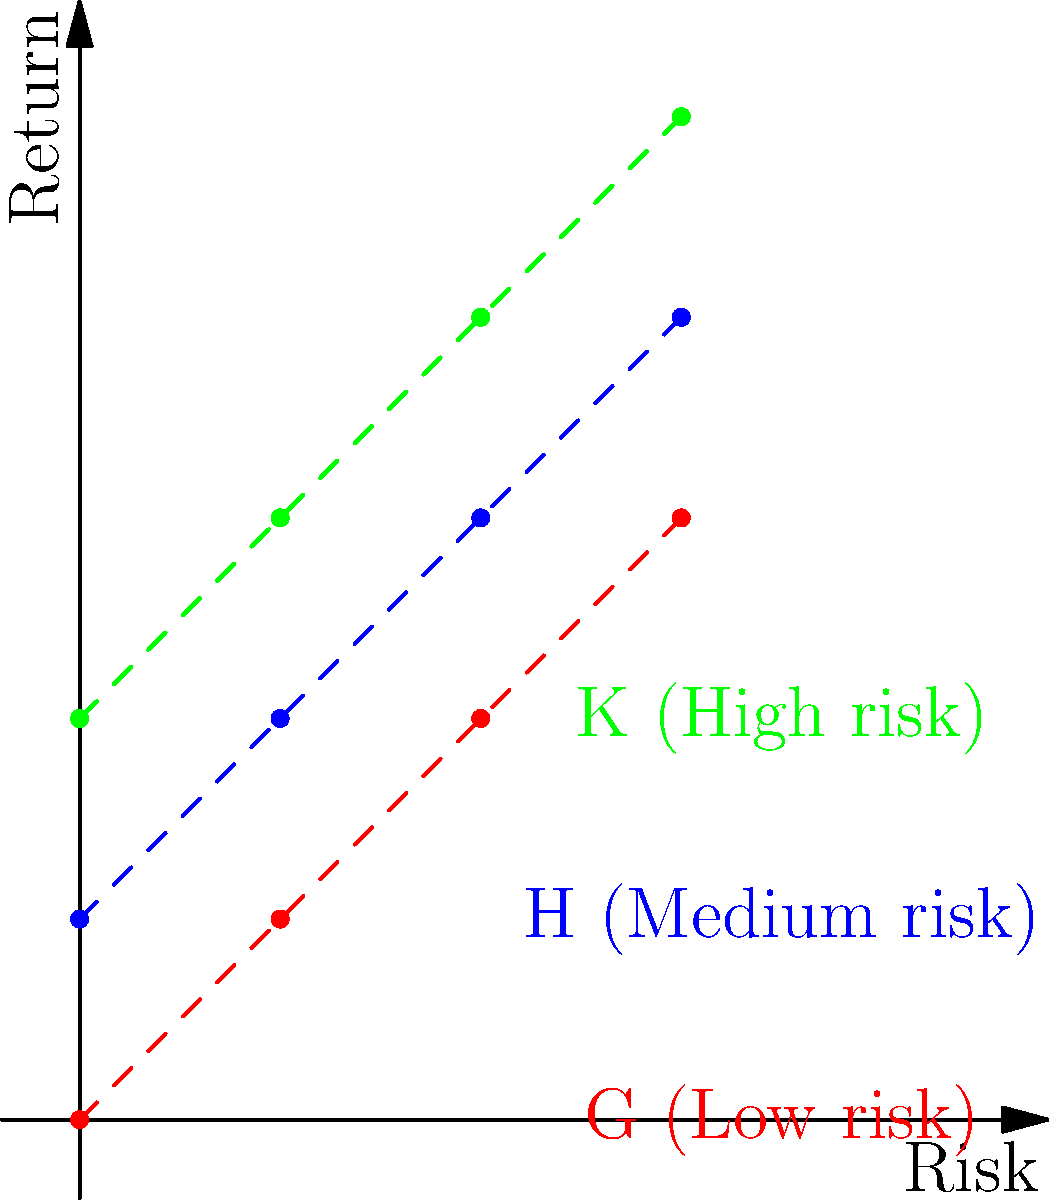In the graph above, financial data points are clustered into three cosets G, H, and K of a subgroup of translations in $\mathbb{R}^2$. If we define the operation $\oplus$ as vector addition modulo 4 for both coordinates, which of the following statements is true about the coset structure?

a) H = G $\oplus$ (0,1)
b) K = G $\oplus$ (0,2)
c) H $\oplus$ K = G
d) All of the above Let's analyze this step-by-step:

1) First, we need to understand what the operation $\oplus$ means. It's vector addition modulo 4 for both coordinates. This means we add the vectors normally, then take the result modulo 4 for each coordinate.

2) Let's check statement a): H = G $\oplus$ (0,1)
   For each point in G, we add (0,1) and take modulo 4:
   (0,0) $\oplus$ (0,1) = (0,1) mod 4 = (0,1)
   (1,1) $\oplus$ (0,1) = (1,2) mod 4 = (1,2)
   (2,2) $\oplus$ (0,1) = (2,3) mod 4 = (2,3)
   (3,3) $\oplus$ (0,1) = (3,4) mod 4 = (3,0)
   This matches the points in H, so statement a) is true.

3) Let's check statement b): K = G $\oplus$ (0,2)
   Similarly:
   (0,0) $\oplus$ (0,2) = (0,2) mod 4 = (0,2)
   (1,1) $\oplus$ (0,2) = (1,3) mod 4 = (1,3)
   (2,2) $\oplus$ (0,2) = (2,4) mod 4 = (2,0)
   (3,3) $\oplus$ (0,2) = (3,5) mod 4 = (3,1)
   This matches the points in K, so statement b) is true.

4) Let's check statement c): H $\oplus$ K = G
   We need to check if adding each point in H to each point in K (modulo 4) gives us the points in G:
   (0,1) $\oplus$ (0,2) = (0,3) mod 4 = (0,3)
   (1,2) $\oplus$ (1,3) = (2,5) mod 4 = (2,1)
   (2,3) $\oplus$ (2,4) = (4,7) mod 4 = (0,3)
   (3,0) $\oplus$ (3,1) = (6,1) mod 4 = (2,1)
   This does not match the points in G, so statement c) is false.

5) Since statements a) and b) are true, but c) is false, the correct answer is not "All of the above".
Answer: a) and b) only 